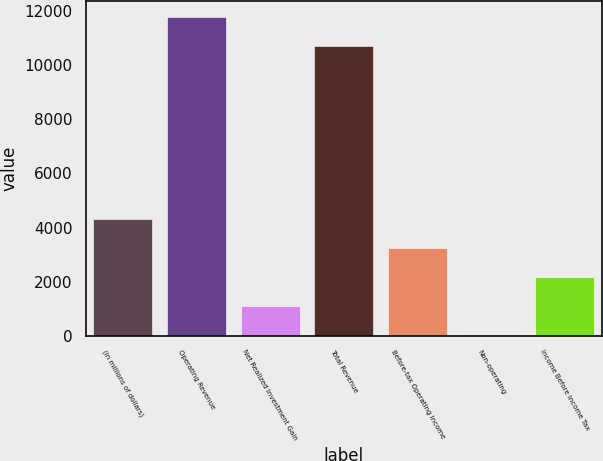Convert chart. <chart><loc_0><loc_0><loc_500><loc_500><bar_chart><fcel>(in millions of dollars)<fcel>Operating Revenue<fcel>Net Realized Investment Gain<fcel>Total Revenue<fcel>Before-tax Operating Income<fcel>Non-operating<fcel>Income Before Income Tax<nl><fcel>4317.18<fcel>11807.6<fcel>1088.22<fcel>10731.3<fcel>3240.86<fcel>11.9<fcel>2164.54<nl></chart> 